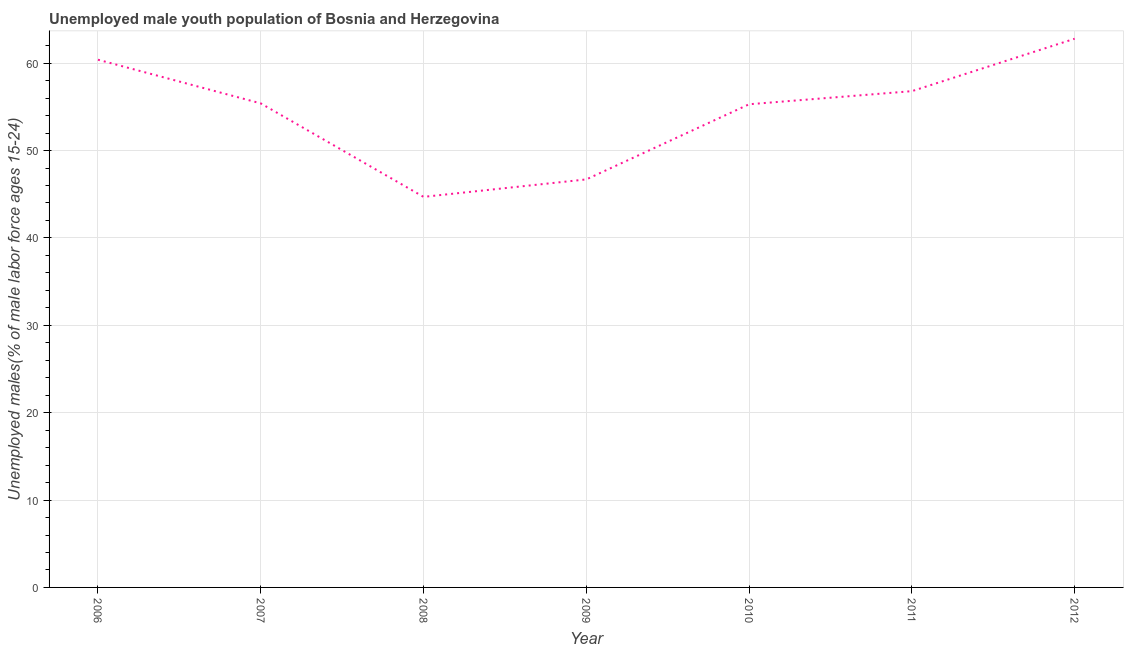What is the unemployed male youth in 2012?
Give a very brief answer. 62.8. Across all years, what is the maximum unemployed male youth?
Offer a very short reply. 62.8. Across all years, what is the minimum unemployed male youth?
Make the answer very short. 44.7. What is the sum of the unemployed male youth?
Offer a very short reply. 382.1. What is the average unemployed male youth per year?
Your response must be concise. 54.59. What is the median unemployed male youth?
Your answer should be compact. 55.4. In how many years, is the unemployed male youth greater than 8 %?
Your answer should be compact. 7. Do a majority of the years between 2006 and 2007 (inclusive) have unemployed male youth greater than 48 %?
Your response must be concise. Yes. What is the ratio of the unemployed male youth in 2008 to that in 2011?
Offer a very short reply. 0.79. Is the unemployed male youth in 2008 less than that in 2012?
Offer a terse response. Yes. Is the difference between the unemployed male youth in 2006 and 2011 greater than the difference between any two years?
Your answer should be very brief. No. What is the difference between the highest and the second highest unemployed male youth?
Keep it short and to the point. 2.4. What is the difference between the highest and the lowest unemployed male youth?
Keep it short and to the point. 18.1. Does the unemployed male youth monotonically increase over the years?
Offer a terse response. No. How many years are there in the graph?
Your response must be concise. 7. Are the values on the major ticks of Y-axis written in scientific E-notation?
Give a very brief answer. No. Does the graph contain any zero values?
Offer a very short reply. No. What is the title of the graph?
Give a very brief answer. Unemployed male youth population of Bosnia and Herzegovina. What is the label or title of the Y-axis?
Your response must be concise. Unemployed males(% of male labor force ages 15-24). What is the Unemployed males(% of male labor force ages 15-24) of 2006?
Give a very brief answer. 60.4. What is the Unemployed males(% of male labor force ages 15-24) in 2007?
Provide a succinct answer. 55.4. What is the Unemployed males(% of male labor force ages 15-24) of 2008?
Offer a very short reply. 44.7. What is the Unemployed males(% of male labor force ages 15-24) of 2009?
Make the answer very short. 46.7. What is the Unemployed males(% of male labor force ages 15-24) of 2010?
Your response must be concise. 55.3. What is the Unemployed males(% of male labor force ages 15-24) of 2011?
Your response must be concise. 56.8. What is the Unemployed males(% of male labor force ages 15-24) of 2012?
Your answer should be compact. 62.8. What is the difference between the Unemployed males(% of male labor force ages 15-24) in 2006 and 2010?
Offer a very short reply. 5.1. What is the difference between the Unemployed males(% of male labor force ages 15-24) in 2006 and 2012?
Offer a very short reply. -2.4. What is the difference between the Unemployed males(% of male labor force ages 15-24) in 2007 and 2011?
Provide a succinct answer. -1.4. What is the difference between the Unemployed males(% of male labor force ages 15-24) in 2008 and 2011?
Make the answer very short. -12.1. What is the difference between the Unemployed males(% of male labor force ages 15-24) in 2008 and 2012?
Provide a short and direct response. -18.1. What is the difference between the Unemployed males(% of male labor force ages 15-24) in 2009 and 2010?
Ensure brevity in your answer.  -8.6. What is the difference between the Unemployed males(% of male labor force ages 15-24) in 2009 and 2012?
Provide a succinct answer. -16.1. What is the difference between the Unemployed males(% of male labor force ages 15-24) in 2010 and 2011?
Offer a terse response. -1.5. What is the difference between the Unemployed males(% of male labor force ages 15-24) in 2010 and 2012?
Provide a short and direct response. -7.5. What is the ratio of the Unemployed males(% of male labor force ages 15-24) in 2006 to that in 2007?
Ensure brevity in your answer.  1.09. What is the ratio of the Unemployed males(% of male labor force ages 15-24) in 2006 to that in 2008?
Give a very brief answer. 1.35. What is the ratio of the Unemployed males(% of male labor force ages 15-24) in 2006 to that in 2009?
Provide a short and direct response. 1.29. What is the ratio of the Unemployed males(% of male labor force ages 15-24) in 2006 to that in 2010?
Ensure brevity in your answer.  1.09. What is the ratio of the Unemployed males(% of male labor force ages 15-24) in 2006 to that in 2011?
Give a very brief answer. 1.06. What is the ratio of the Unemployed males(% of male labor force ages 15-24) in 2006 to that in 2012?
Provide a succinct answer. 0.96. What is the ratio of the Unemployed males(% of male labor force ages 15-24) in 2007 to that in 2008?
Your response must be concise. 1.24. What is the ratio of the Unemployed males(% of male labor force ages 15-24) in 2007 to that in 2009?
Offer a very short reply. 1.19. What is the ratio of the Unemployed males(% of male labor force ages 15-24) in 2007 to that in 2012?
Provide a succinct answer. 0.88. What is the ratio of the Unemployed males(% of male labor force ages 15-24) in 2008 to that in 2009?
Provide a short and direct response. 0.96. What is the ratio of the Unemployed males(% of male labor force ages 15-24) in 2008 to that in 2010?
Offer a very short reply. 0.81. What is the ratio of the Unemployed males(% of male labor force ages 15-24) in 2008 to that in 2011?
Ensure brevity in your answer.  0.79. What is the ratio of the Unemployed males(% of male labor force ages 15-24) in 2008 to that in 2012?
Make the answer very short. 0.71. What is the ratio of the Unemployed males(% of male labor force ages 15-24) in 2009 to that in 2010?
Your response must be concise. 0.84. What is the ratio of the Unemployed males(% of male labor force ages 15-24) in 2009 to that in 2011?
Offer a terse response. 0.82. What is the ratio of the Unemployed males(% of male labor force ages 15-24) in 2009 to that in 2012?
Keep it short and to the point. 0.74. What is the ratio of the Unemployed males(% of male labor force ages 15-24) in 2010 to that in 2012?
Make the answer very short. 0.88. What is the ratio of the Unemployed males(% of male labor force ages 15-24) in 2011 to that in 2012?
Offer a terse response. 0.9. 